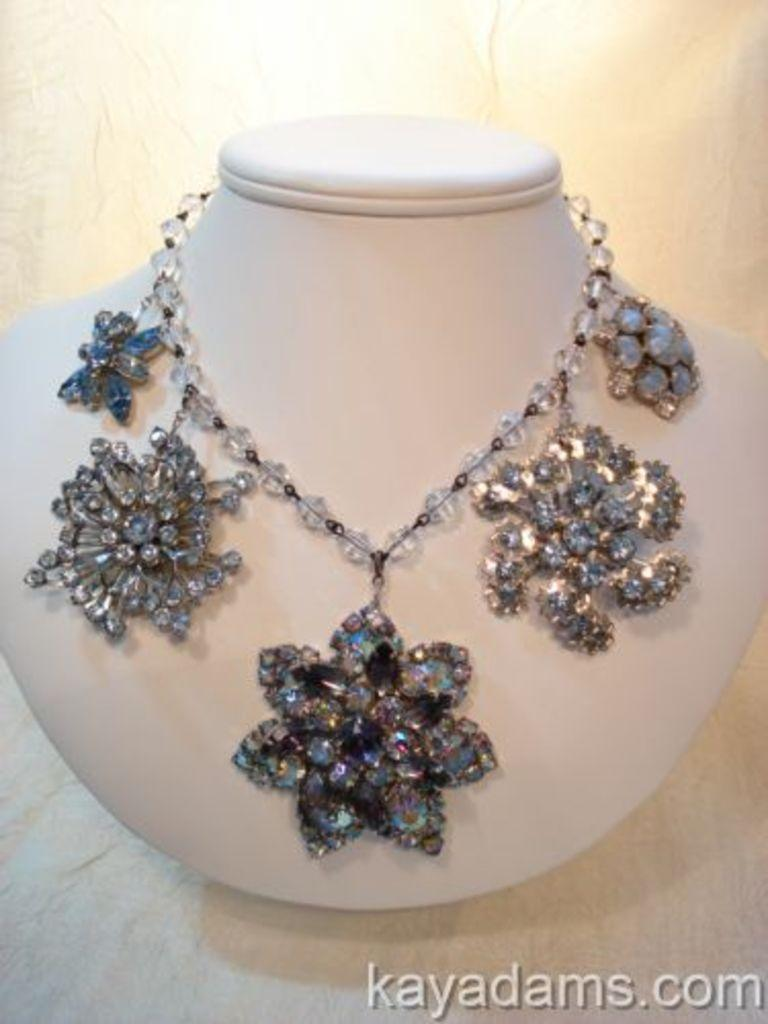What type of accessory is on the mannequin in the image? There is a necklace on the mannequin's neck. Can you describe any additional features of the image? Yes, there is a watermark on the image. What class of people is the mannequin representing in the image? There is no information about the class of people the mannequin might represent in the image. 